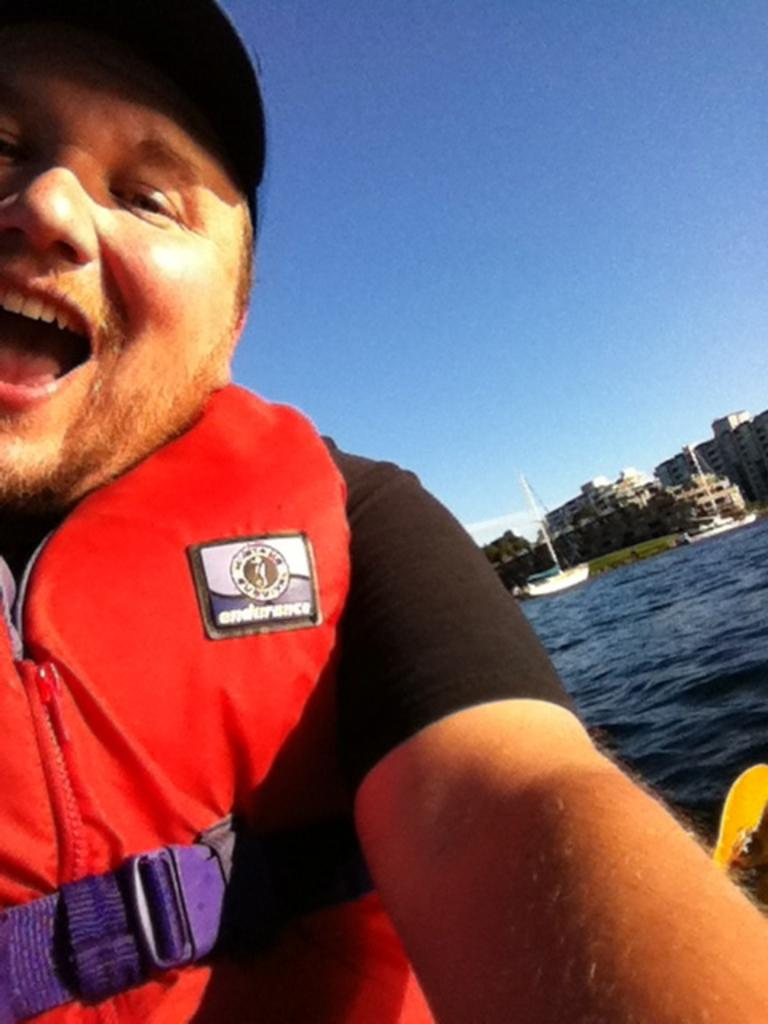Who is present in the image? There is a man in the image. What is the man wearing? The man is wearing a red jacket. What can be seen at the bottom of the image? There is water visible at the bottom of the image. What is visible in the background of the image? There are boats and buildings in the background of the image. What part of the natural environment is visible in the image? The sky is visible at the top of the image. How many babies are present in the image? There are no babies present in the image. What type of squirrel can be seen climbing the red jacket in the image? There is no squirrel present in the image, and the man is not wearing a red jacket with a squirrel climbing it. 